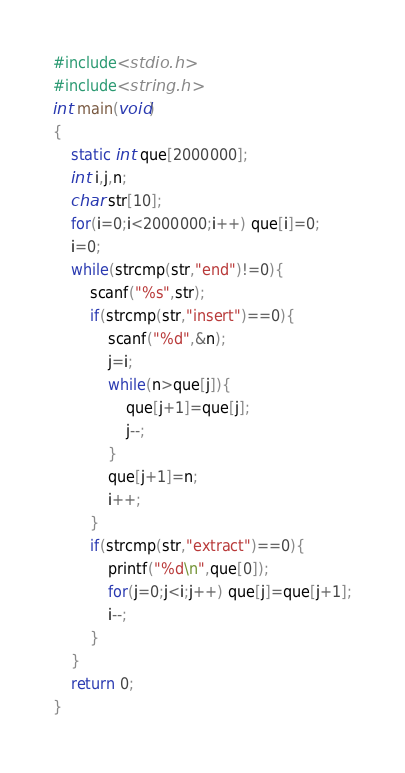Convert code to text. <code><loc_0><loc_0><loc_500><loc_500><_C_>#include<stdio.h>
#include<string.h>
int main(void)
{
    static int que[2000000];
    int i,j,n;
    char str[10];
    for(i=0;i<2000000;i++) que[i]=0;
    i=0;
    while(strcmp(str,"end")!=0){
        scanf("%s",str);
        if(strcmp(str,"insert")==0){
            scanf("%d",&n);
            j=i;
            while(n>que[j]){
                que[j+1]=que[j];
                j--;
            }
            que[j+1]=n;
            i++;
        }
        if(strcmp(str,"extract")==0){
            printf("%d\n",que[0]);
            for(j=0;j<i;j++) que[j]=que[j+1];
            i--;
        }
    }
    return 0;
}</code> 